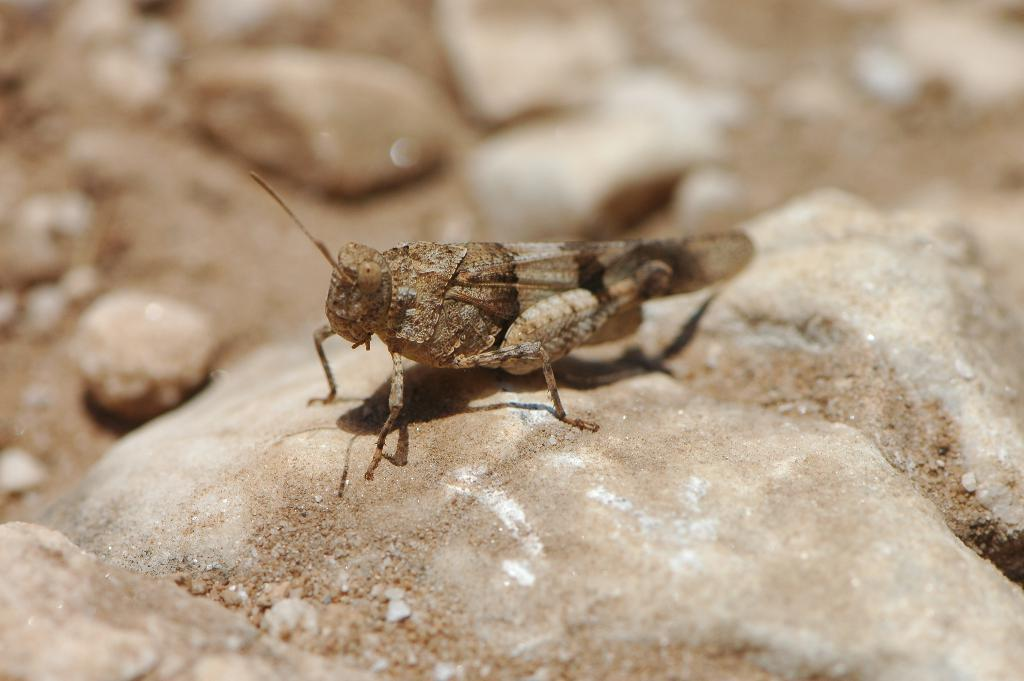What type of creature is present in the image? There is an insect in the image. Where is the insect located? The insect is standing on the grass. What can be seen in the background of the image? There are rocks visible in the background of the image. How does the squirrel use its grip to climb the tree in the image? There is no squirrel present in the image, and therefore no tree or climbing activity can be observed. 